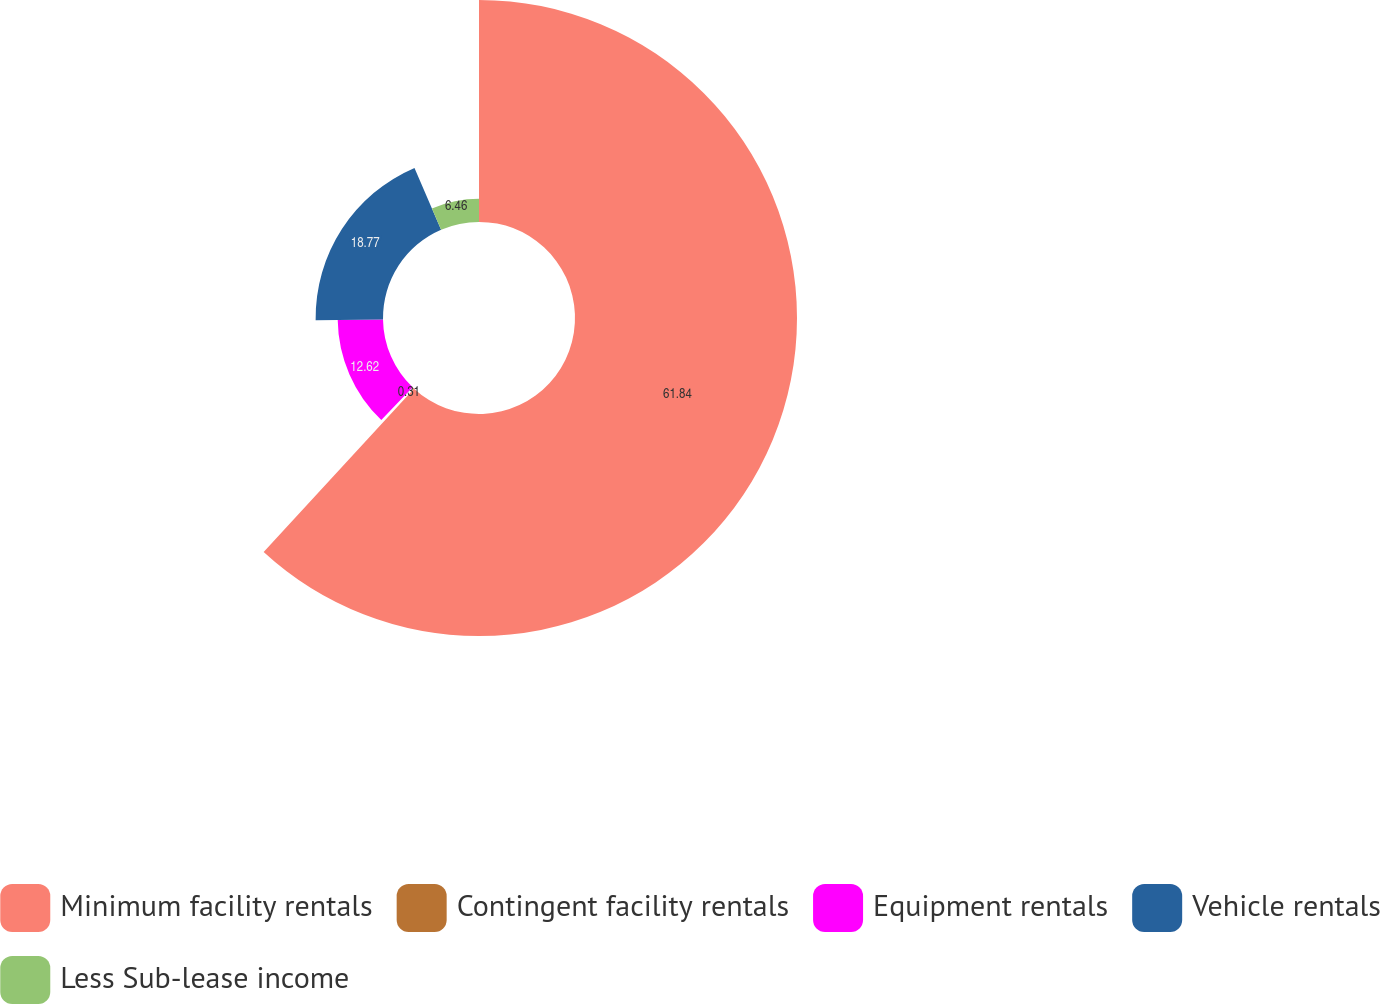Convert chart. <chart><loc_0><loc_0><loc_500><loc_500><pie_chart><fcel>Minimum facility rentals<fcel>Contingent facility rentals<fcel>Equipment rentals<fcel>Vehicle rentals<fcel>Less Sub-lease income<nl><fcel>61.84%<fcel>0.31%<fcel>12.62%<fcel>18.77%<fcel>6.46%<nl></chart> 